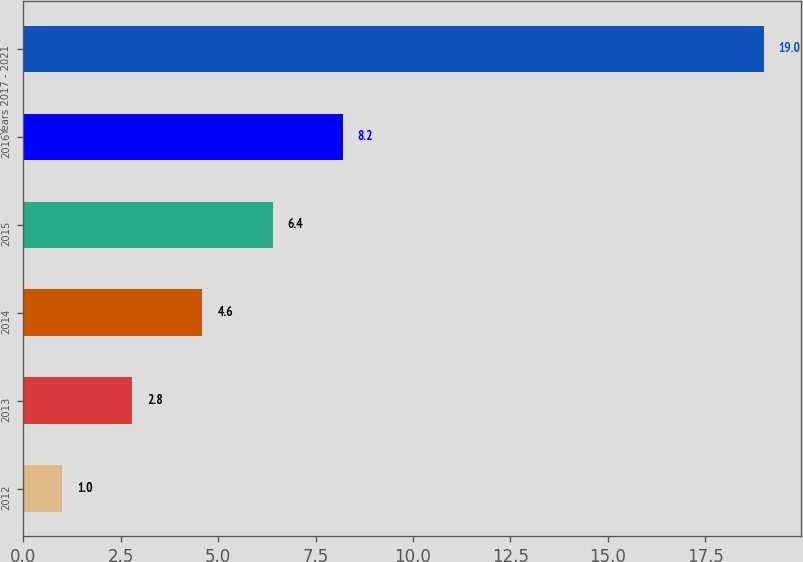Convert chart to OTSL. <chart><loc_0><loc_0><loc_500><loc_500><bar_chart><fcel>2012<fcel>2013<fcel>2014<fcel>2015<fcel>2016<fcel>Years 2017 - 2021<nl><fcel>1<fcel>2.8<fcel>4.6<fcel>6.4<fcel>8.2<fcel>19<nl></chart> 